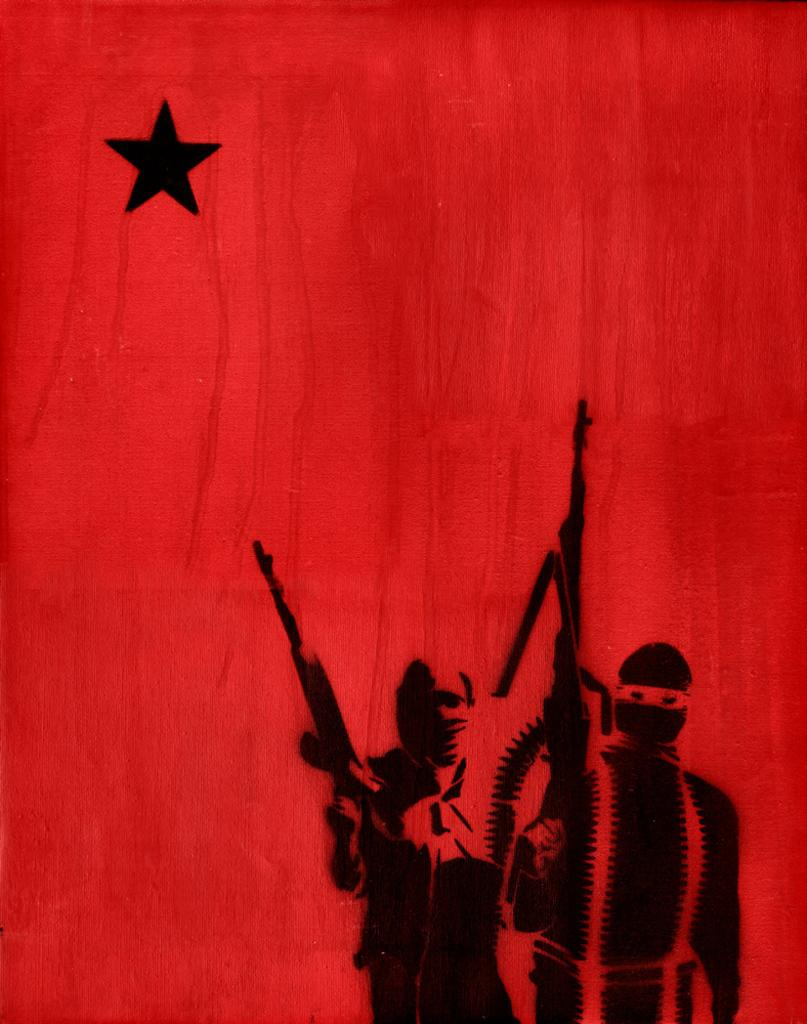What is the main subject of the image? There is a painting in the image. What is depicted in the painting? The painting depicts two men. What are the men doing in the painting? The men are standing and holding guns in the painting. What color is the wall in the painting? The wall in the painting is red. How many screws can be seen on the wall in the painting? There are no screws visible on the wall in the painting; the wall is simply red. 